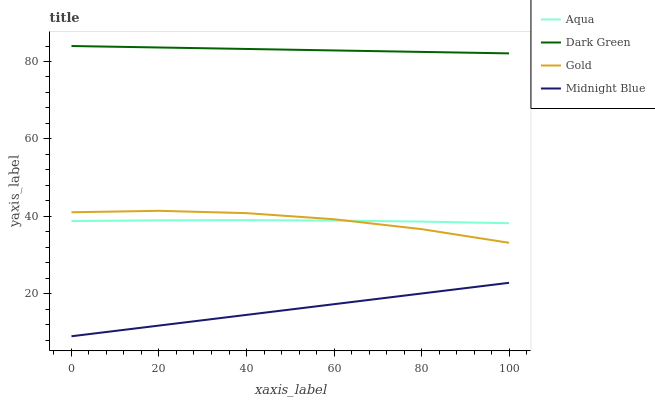Does Midnight Blue have the minimum area under the curve?
Answer yes or no. Yes. Does Dark Green have the maximum area under the curve?
Answer yes or no. Yes. Does Gold have the minimum area under the curve?
Answer yes or no. No. Does Gold have the maximum area under the curve?
Answer yes or no. No. Is Midnight Blue the smoothest?
Answer yes or no. Yes. Is Gold the roughest?
Answer yes or no. Yes. Is Gold the smoothest?
Answer yes or no. No. Is Midnight Blue the roughest?
Answer yes or no. No. Does Midnight Blue have the lowest value?
Answer yes or no. Yes. Does Gold have the lowest value?
Answer yes or no. No. Does Dark Green have the highest value?
Answer yes or no. Yes. Does Gold have the highest value?
Answer yes or no. No. Is Midnight Blue less than Gold?
Answer yes or no. Yes. Is Gold greater than Midnight Blue?
Answer yes or no. Yes. Does Aqua intersect Gold?
Answer yes or no. Yes. Is Aqua less than Gold?
Answer yes or no. No. Is Aqua greater than Gold?
Answer yes or no. No. Does Midnight Blue intersect Gold?
Answer yes or no. No. 